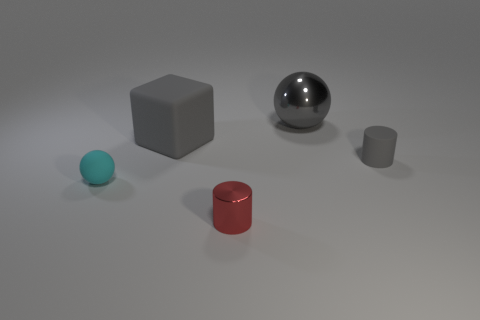Add 3 gray metal things. How many objects exist? 8 Subtract all blocks. How many objects are left? 4 Subtract all gray matte cubes. Subtract all small red metal cylinders. How many objects are left? 3 Add 3 rubber balls. How many rubber balls are left? 4 Add 1 large rubber cylinders. How many large rubber cylinders exist? 1 Subtract 0 cyan blocks. How many objects are left? 5 